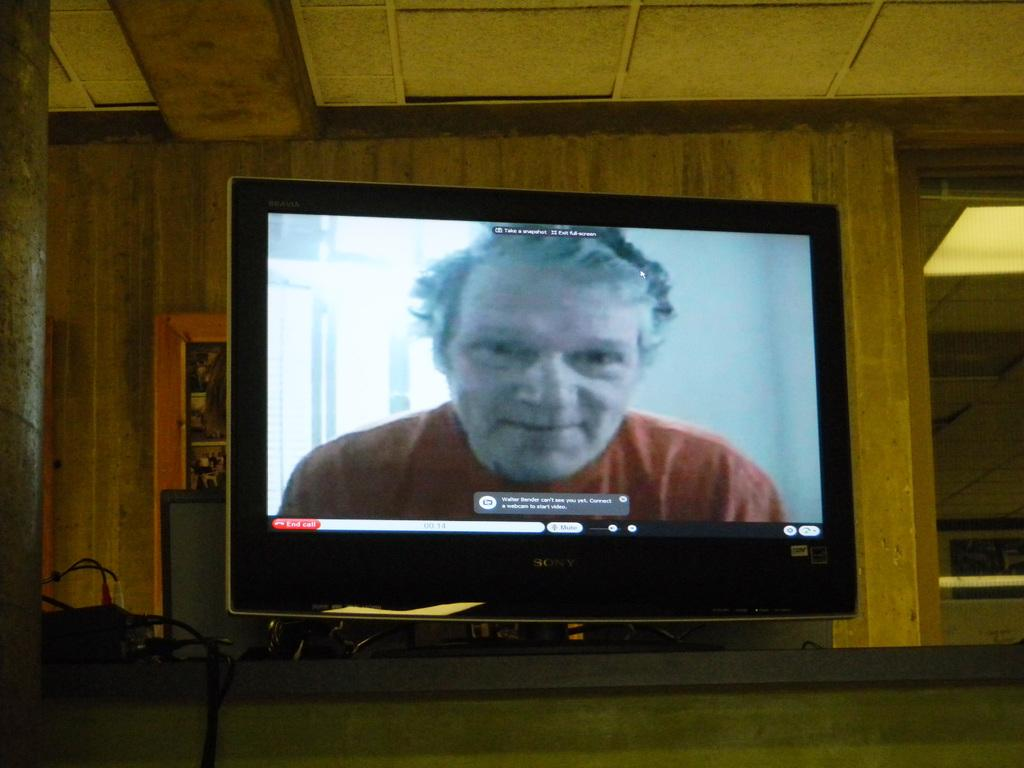Provide a one-sentence caption for the provided image. A man wearing red can be seen on a Sony computer monitor. 